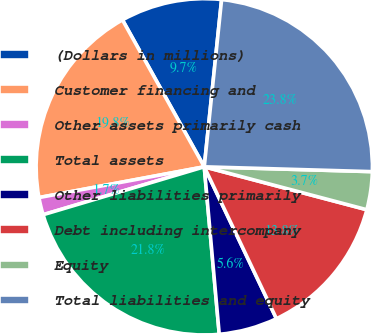Convert chart to OTSL. <chart><loc_0><loc_0><loc_500><loc_500><pie_chart><fcel>(Dollars in millions)<fcel>Customer financing and<fcel>Other assets primarily cash<fcel>Total assets<fcel>Other liabilities primarily<fcel>Debt including intercompany<fcel>Equity<fcel>Total liabilities and equity<nl><fcel>9.73%<fcel>19.84%<fcel>1.67%<fcel>21.82%<fcel>5.64%<fcel>13.83%<fcel>3.65%<fcel>23.81%<nl></chart> 